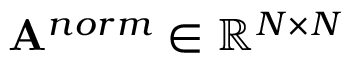Convert formula to latex. <formula><loc_0><loc_0><loc_500><loc_500>A ^ { n o r m } \in \mathbb { R } ^ { N \times N }</formula> 